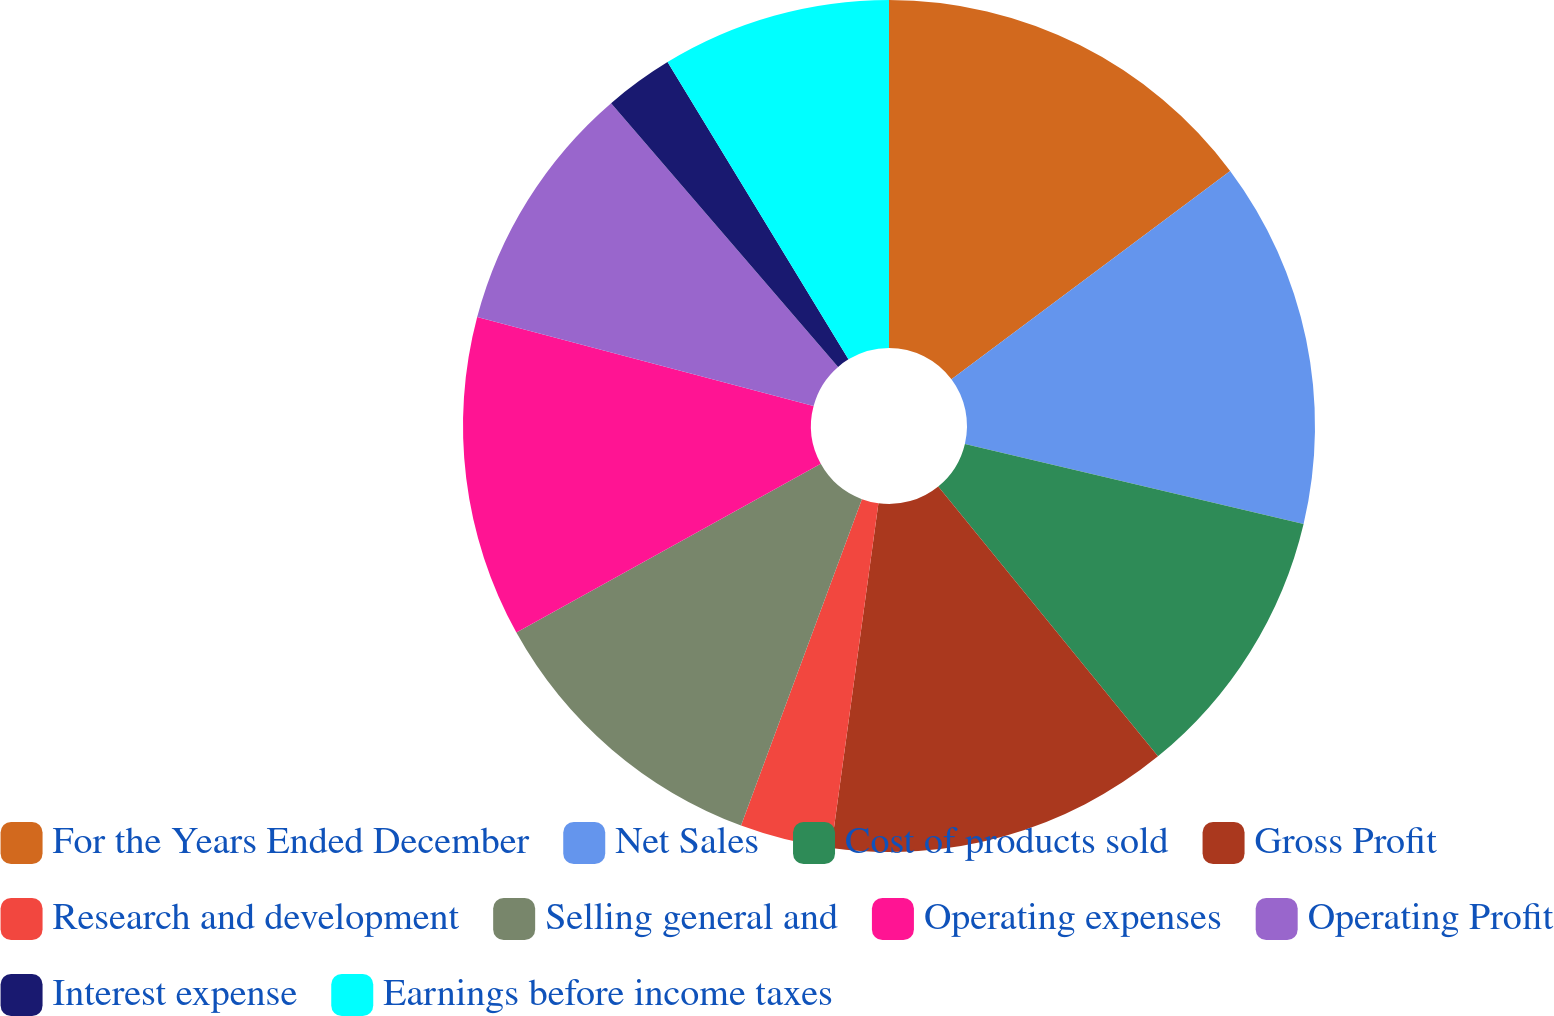Convert chart. <chart><loc_0><loc_0><loc_500><loc_500><pie_chart><fcel>For the Years Ended December<fcel>Net Sales<fcel>Cost of products sold<fcel>Gross Profit<fcel>Research and development<fcel>Selling general and<fcel>Operating expenses<fcel>Operating Profit<fcel>Interest expense<fcel>Earnings before income taxes<nl><fcel>14.78%<fcel>13.91%<fcel>10.43%<fcel>13.04%<fcel>3.48%<fcel>11.3%<fcel>12.17%<fcel>9.57%<fcel>2.61%<fcel>8.7%<nl></chart> 